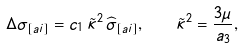Convert formula to latex. <formula><loc_0><loc_0><loc_500><loc_500>\Delta \sigma _ { [ a i ] } = c _ { 1 } \, \tilde { \kappa } ^ { 2 } \, \widehat { \sigma } _ { [ a i ] } , \quad \tilde { \kappa } ^ { 2 } = \frac { 3 \mu } { a _ { 3 } } ,</formula> 